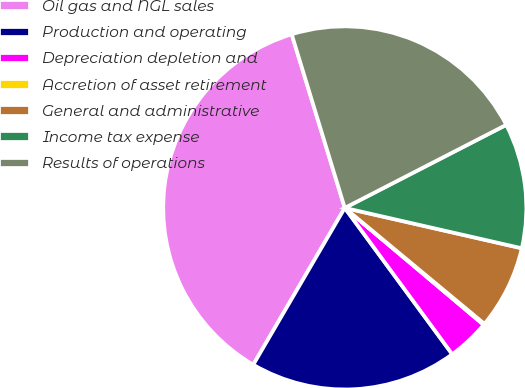<chart> <loc_0><loc_0><loc_500><loc_500><pie_chart><fcel>Oil gas and NGL sales<fcel>Production and operating<fcel>Depreciation depletion and<fcel>Accretion of asset retirement<fcel>General and administrative<fcel>Income tax expense<fcel>Results of operations<nl><fcel>36.87%<fcel>18.49%<fcel>3.78%<fcel>0.11%<fcel>7.46%<fcel>11.13%<fcel>22.16%<nl></chart> 